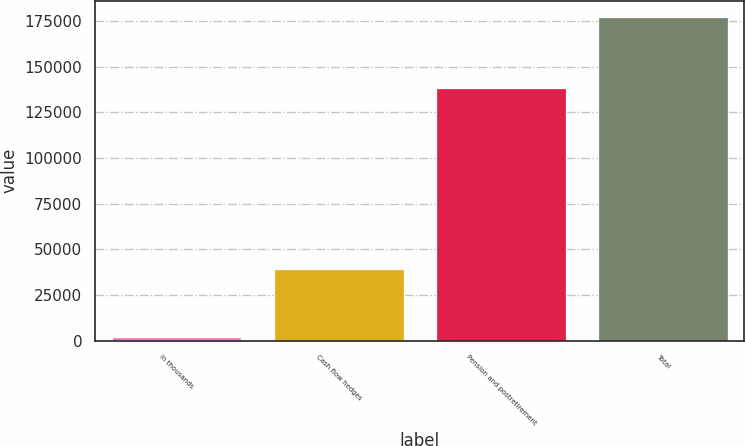Convert chart to OTSL. <chart><loc_0><loc_0><loc_500><loc_500><bar_chart><fcel>in thousands<fcel>Cash flow hedges<fcel>Pension and postretirement<fcel>Total<nl><fcel>2010<fcel>39137<fcel>138202<fcel>177339<nl></chart> 